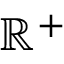Convert formula to latex. <formula><loc_0><loc_0><loc_500><loc_500>\mathbb { R } ^ { + }</formula> 